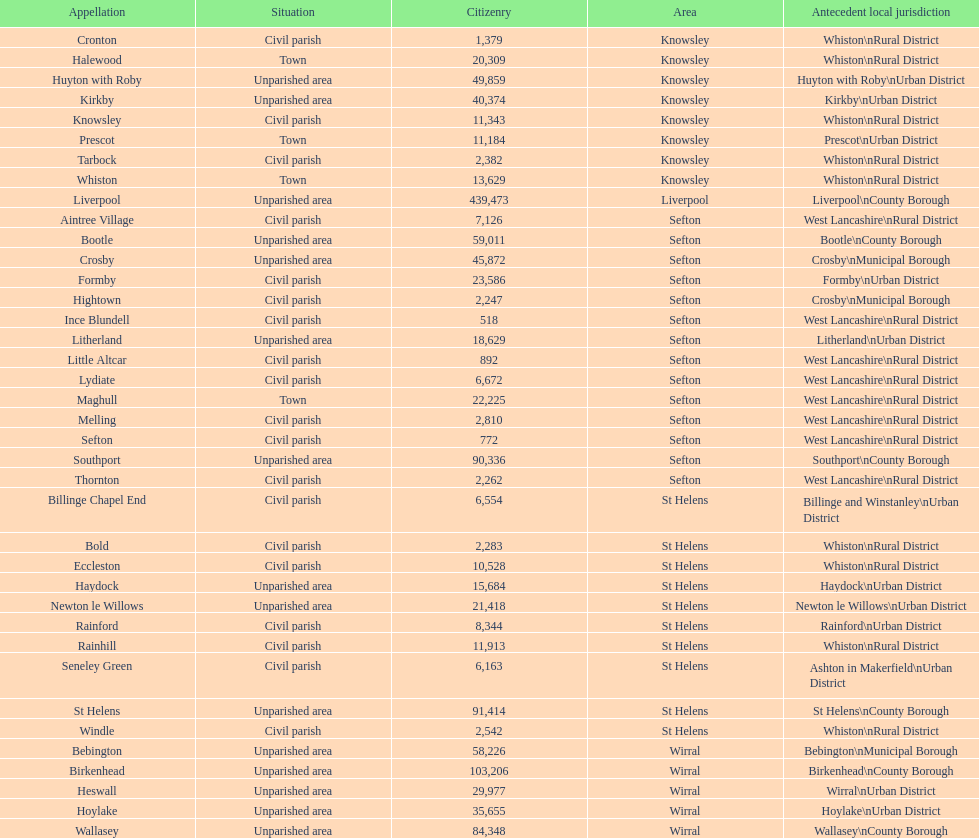How many people live in the bold civil parish? 2,283. 